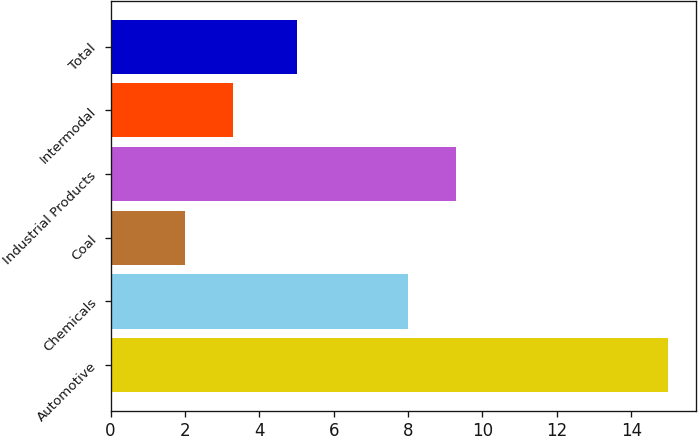Convert chart to OTSL. <chart><loc_0><loc_0><loc_500><loc_500><bar_chart><fcel>Automotive<fcel>Chemicals<fcel>Coal<fcel>Industrial Products<fcel>Intermodal<fcel>Total<nl><fcel>15<fcel>8<fcel>2<fcel>9.3<fcel>3.3<fcel>5<nl></chart> 